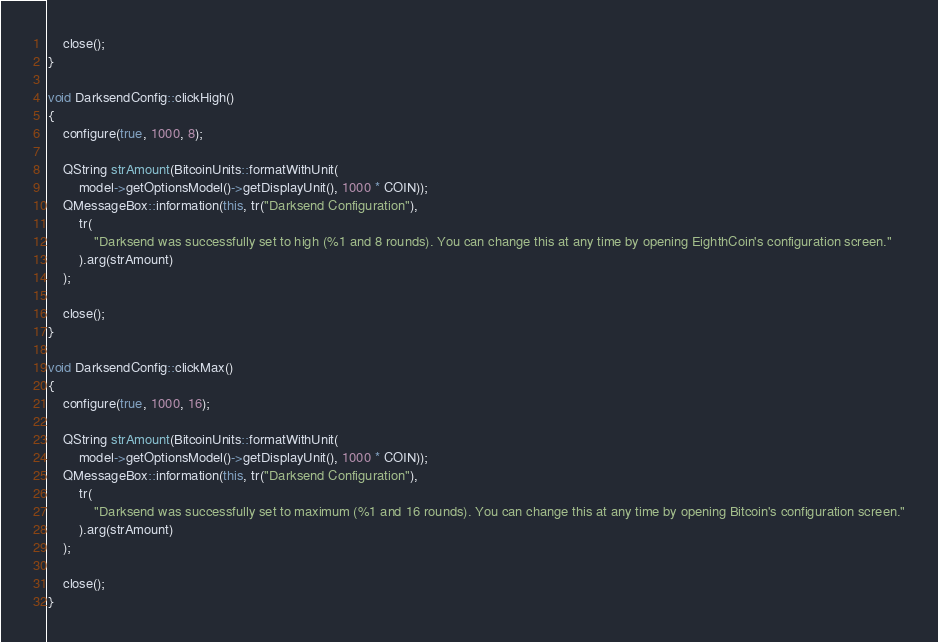Convert code to text. <code><loc_0><loc_0><loc_500><loc_500><_C++_>    close();
}

void DarksendConfig::clickHigh()
{
    configure(true, 1000, 8);

    QString strAmount(BitcoinUnits::formatWithUnit(
        model->getOptionsModel()->getDisplayUnit(), 1000 * COIN));
    QMessageBox::information(this, tr("Darksend Configuration"),
        tr(
            "Darksend was successfully set to high (%1 and 8 rounds). You can change this at any time by opening EighthCoin's configuration screen."
        ).arg(strAmount)
    );

    close();
}

void DarksendConfig::clickMax()
{
    configure(true, 1000, 16);

    QString strAmount(BitcoinUnits::formatWithUnit(
        model->getOptionsModel()->getDisplayUnit(), 1000 * COIN));
    QMessageBox::information(this, tr("Darksend Configuration"),
        tr(
            "Darksend was successfully set to maximum (%1 and 16 rounds). You can change this at any time by opening Bitcoin's configuration screen."
        ).arg(strAmount)
    );

    close();
}
</code> 